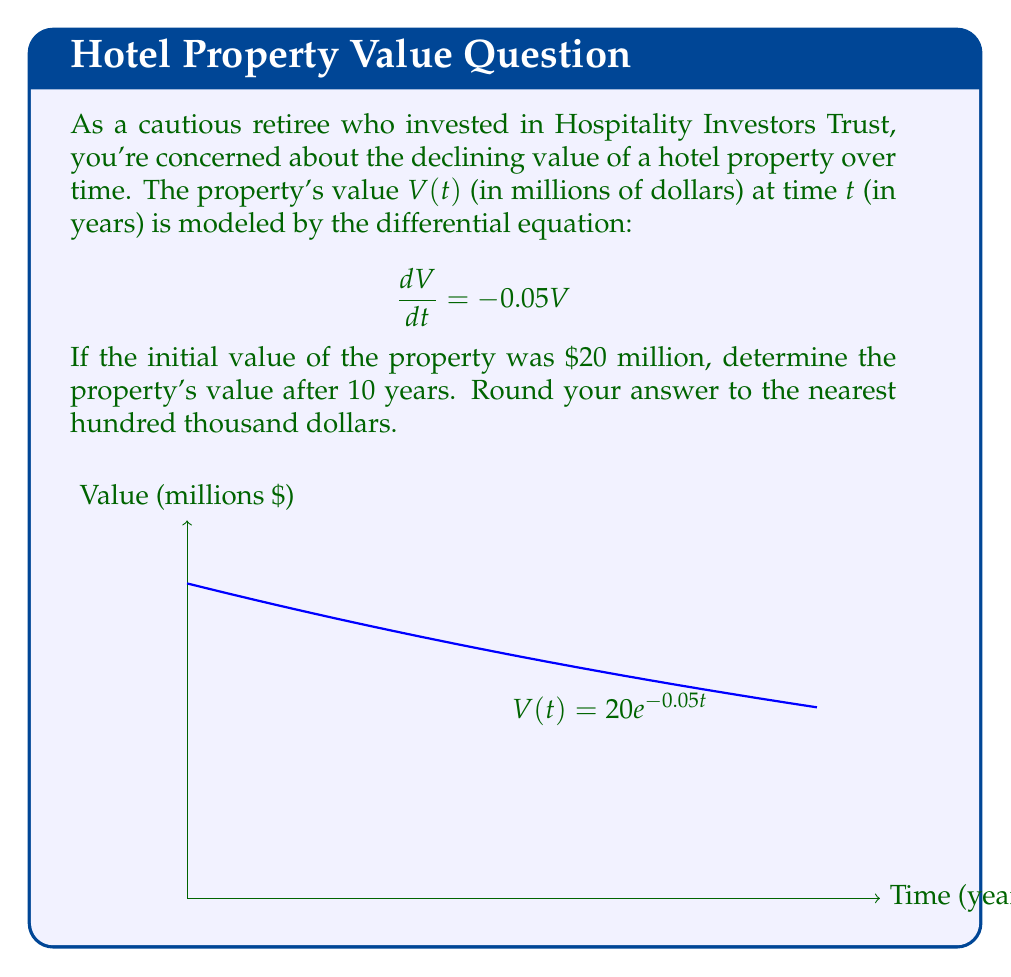Show me your answer to this math problem. Let's solve this step-by-step:

1) The given differential equation is:
   $$\frac{dV}{dt} = -0.05V$$

2) This is a first-order linear differential equation with constant coefficients. The general solution is:
   $$V(t) = Ce^{-0.05t}$$
   where $C$ is a constant determined by the initial condition.

3) We're given that $V(0) = 20$ million. Let's use this to find $C$:
   $$20 = Ce^{-0.05(0)} = C$$

4) So our specific solution is:
   $$V(t) = 20e^{-0.05t}$$

5) To find the value after 10 years, we calculate $V(10)$:
   $$V(10) = 20e^{-0.05(10)} = 20e^{-0.5} \approx 12.18$$

6) Converting to dollars and rounding to the nearest hundred thousand:
   $12.18 million ≈ $12,200,000
Answer: $12,200,000 